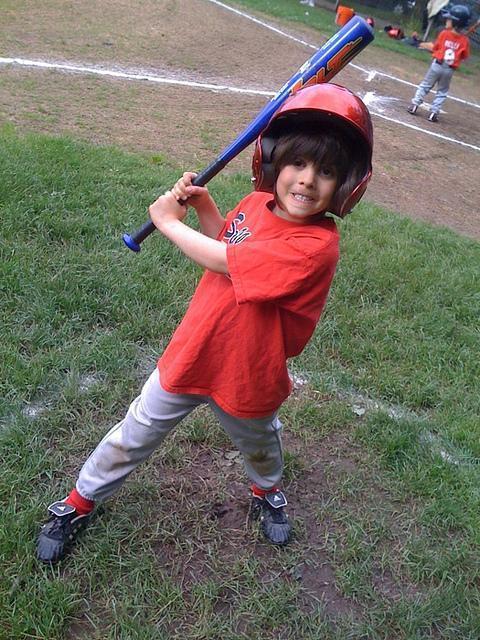How many people are in the photo?
Give a very brief answer. 2. 